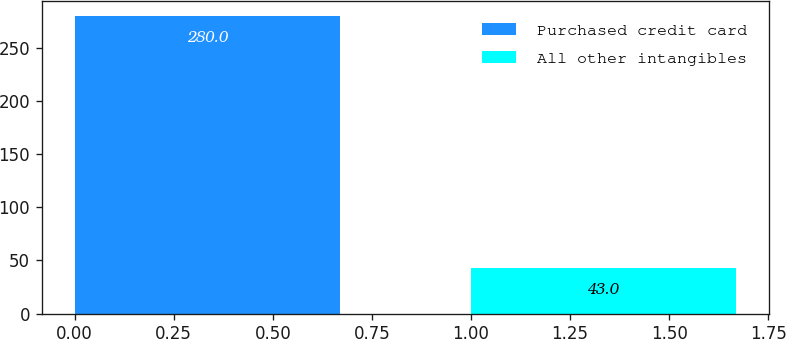<chart> <loc_0><loc_0><loc_500><loc_500><bar_chart><fcel>Purchased credit card<fcel>All other intangibles<nl><fcel>280<fcel>43<nl></chart> 